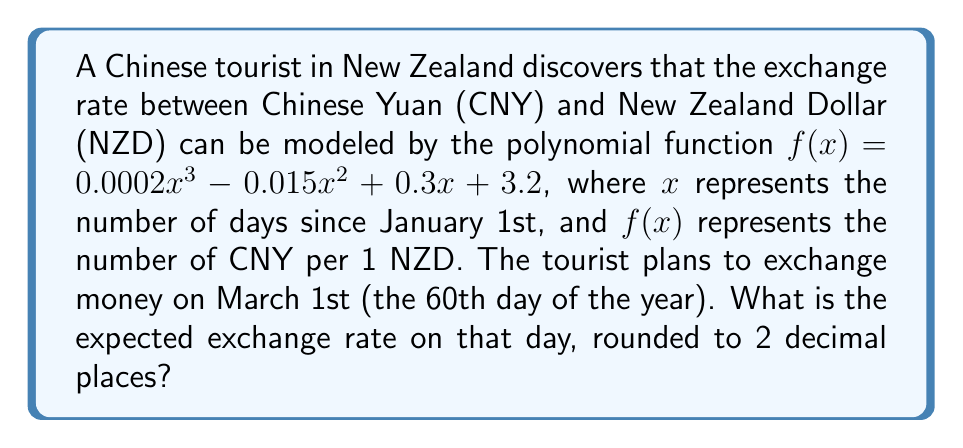Could you help me with this problem? To solve this problem, we need to follow these steps:

1. Identify the given polynomial function:
   $f(x) = 0.0002x^3 - 0.015x^2 + 0.3x + 3.2$

2. Determine the value of $x$ for March 1st:
   March 1st is the 60th day of the year, so $x = 60$

3. Substitute $x = 60$ into the polynomial function:
   $f(60) = 0.0002(60)^3 - 0.015(60)^2 + 0.3(60) + 3.2$

4. Calculate each term:
   $0.0002(60)^3 = 0.0002 \times 216000 = 43.2$
   $-0.015(60)^2 = -0.015 \times 3600 = -54$
   $0.3(60) = 18$
   $3.2$ remains as is

5. Sum up all the terms:
   $f(60) = 43.2 - 54 + 18 + 3.2 = 10.4$

6. Round the result to 2 decimal places:
   $10.4$ is already rounded to 2 decimal places

Therefore, the expected exchange rate on March 1st is 10.4 CNY per 1 NZD.
Answer: 10.40 CNY per 1 NZD 